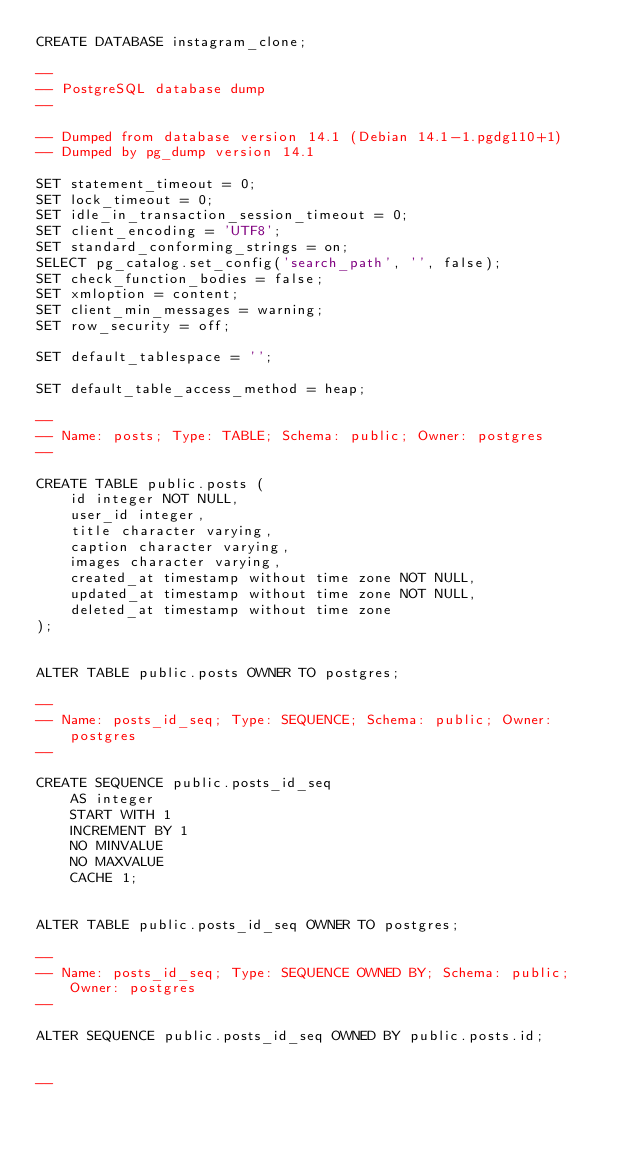Convert code to text. <code><loc_0><loc_0><loc_500><loc_500><_SQL_>CREATE DATABASE instagram_clone;

--
-- PostgreSQL database dump
--

-- Dumped from database version 14.1 (Debian 14.1-1.pgdg110+1)
-- Dumped by pg_dump version 14.1

SET statement_timeout = 0;
SET lock_timeout = 0;
SET idle_in_transaction_session_timeout = 0;
SET client_encoding = 'UTF8';
SET standard_conforming_strings = on;
SELECT pg_catalog.set_config('search_path', '', false);
SET check_function_bodies = false;
SET xmloption = content;
SET client_min_messages = warning;
SET row_security = off;

SET default_tablespace = '';

SET default_table_access_method = heap;

--
-- Name: posts; Type: TABLE; Schema: public; Owner: postgres
--

CREATE TABLE public.posts (
    id integer NOT NULL,
    user_id integer,
    title character varying,
    caption character varying,
    images character varying,
    created_at timestamp without time zone NOT NULL,
    updated_at timestamp without time zone NOT NULL,
    deleted_at timestamp without time zone
);


ALTER TABLE public.posts OWNER TO postgres;

--
-- Name: posts_id_seq; Type: SEQUENCE; Schema: public; Owner: postgres
--

CREATE SEQUENCE public.posts_id_seq
    AS integer
    START WITH 1
    INCREMENT BY 1
    NO MINVALUE
    NO MAXVALUE
    CACHE 1;


ALTER TABLE public.posts_id_seq OWNER TO postgres;

--
-- Name: posts_id_seq; Type: SEQUENCE OWNED BY; Schema: public; Owner: postgres
--

ALTER SEQUENCE public.posts_id_seq OWNED BY public.posts.id;


--</code> 